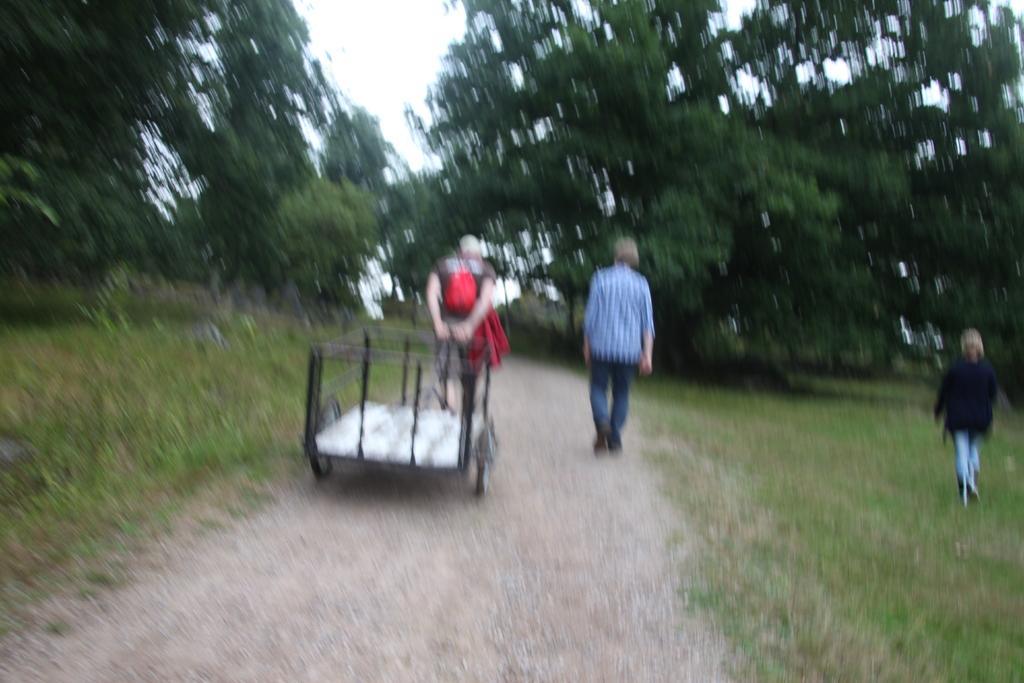How would you summarize this image in a sentence or two? This image is slightly blurred, where we can see we can see this person wearing red bag is moving the trolley on the road and this person is walking on the road. Here we can see this person wearing black dress is walking on the grass. In the background, we can see trees and the sky. 